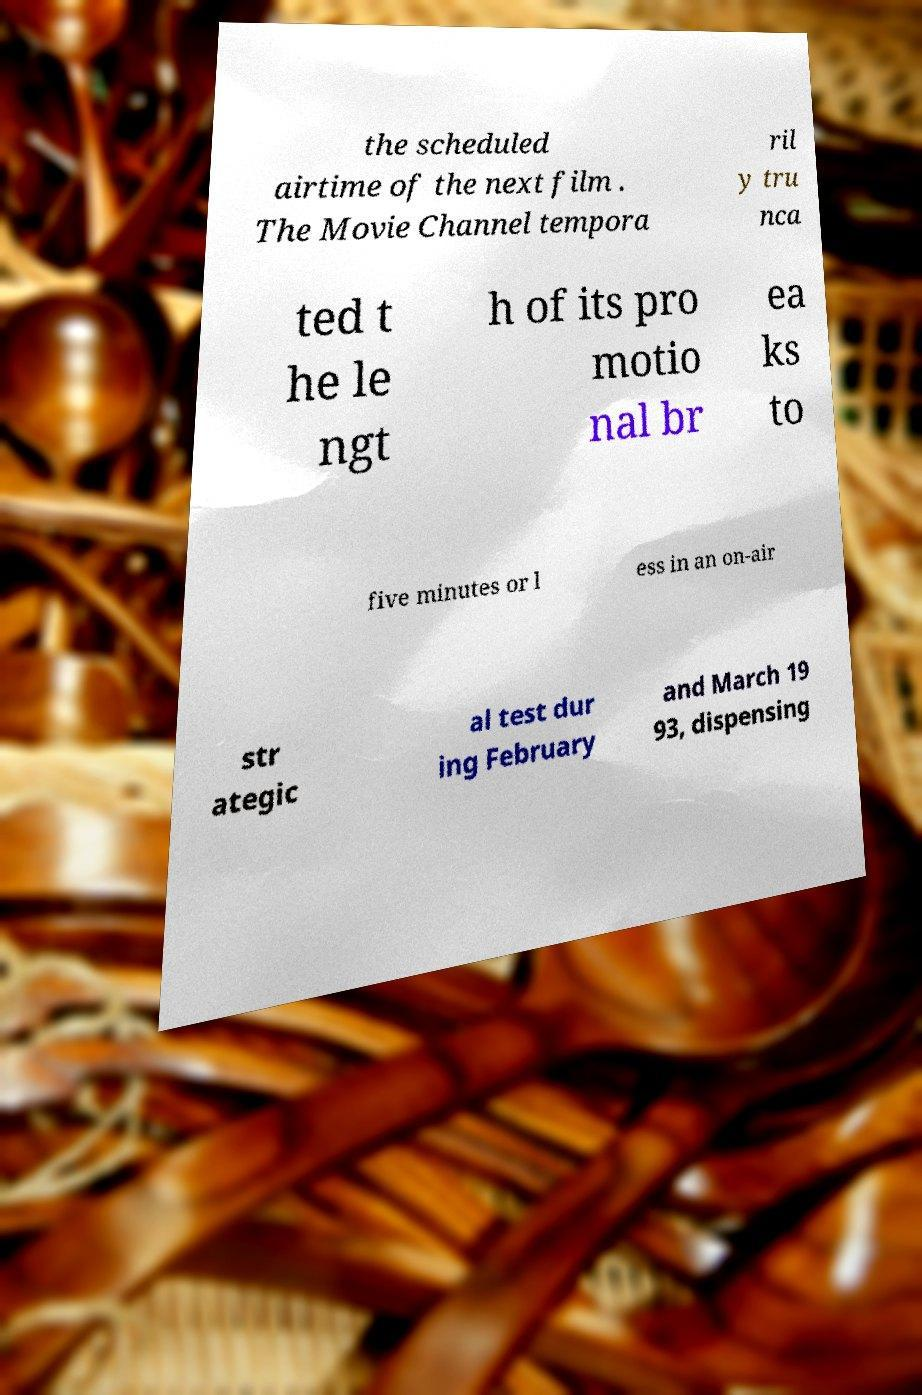Could you assist in decoding the text presented in this image and type it out clearly? the scheduled airtime of the next film . The Movie Channel tempora ril y tru nca ted t he le ngt h of its pro motio nal br ea ks to five minutes or l ess in an on-air str ategic al test dur ing February and March 19 93, dispensing 